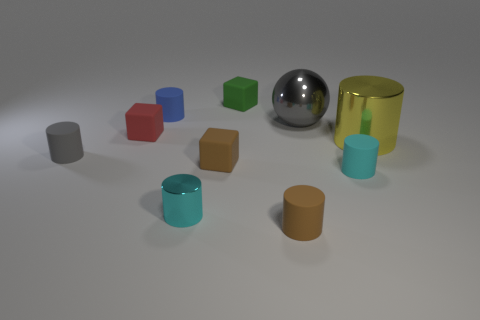Subtract all small cylinders. How many cylinders are left? 1 Subtract all blue cubes. How many cyan cylinders are left? 2 Subtract all green blocks. How many blocks are left? 2 Subtract all spheres. How many objects are left? 9 Subtract 5 cylinders. How many cylinders are left? 1 Subtract all gray cubes. Subtract all blue cylinders. How many cubes are left? 3 Subtract all cyan metal cylinders. Subtract all blue things. How many objects are left? 8 Add 8 cyan metal cylinders. How many cyan metal cylinders are left? 9 Add 2 tiny brown blocks. How many tiny brown blocks exist? 3 Subtract 1 blue cylinders. How many objects are left? 9 